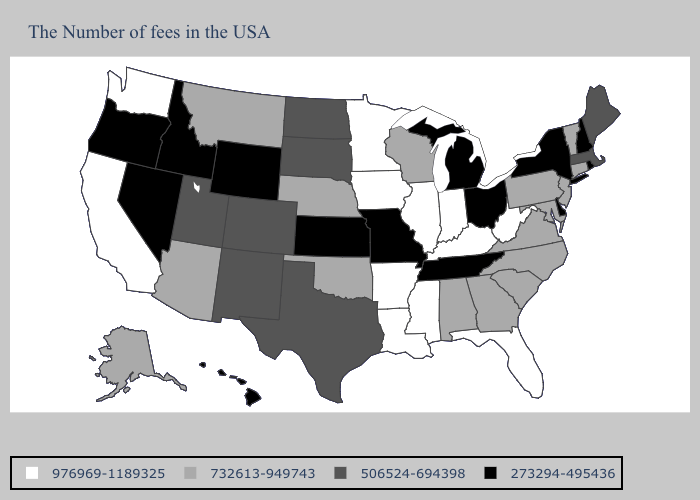What is the value of Delaware?
Be succinct. 273294-495436. Does Tennessee have the lowest value in the South?
Give a very brief answer. Yes. Is the legend a continuous bar?
Short answer required. No. Among the states that border Alabama , does Georgia have the lowest value?
Short answer required. No. What is the highest value in the USA?
Short answer required. 976969-1189325. What is the value of Alabama?
Quick response, please. 732613-949743. Which states have the highest value in the USA?
Keep it brief. West Virginia, Florida, Kentucky, Indiana, Illinois, Mississippi, Louisiana, Arkansas, Minnesota, Iowa, California, Washington. What is the value of Texas?
Write a very short answer. 506524-694398. Does Colorado have a higher value than New York?
Quick response, please. Yes. Among the states that border New Jersey , which have the highest value?
Keep it brief. Pennsylvania. Does Idaho have the same value as Missouri?
Short answer required. Yes. Name the states that have a value in the range 732613-949743?
Quick response, please. Vermont, Connecticut, New Jersey, Maryland, Pennsylvania, Virginia, North Carolina, South Carolina, Georgia, Alabama, Wisconsin, Nebraska, Oklahoma, Montana, Arizona, Alaska. Does Delaware have the lowest value in the USA?
Concise answer only. Yes. Name the states that have a value in the range 506524-694398?
Keep it brief. Maine, Massachusetts, Texas, South Dakota, North Dakota, Colorado, New Mexico, Utah. What is the value of Alabama?
Short answer required. 732613-949743. 